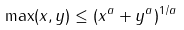Convert formula to latex. <formula><loc_0><loc_0><loc_500><loc_500>\max ( x , y ) \leq ( x ^ { a } + y ^ { a } ) ^ { 1 / a }</formula> 